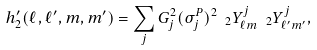<formula> <loc_0><loc_0><loc_500><loc_500>h ^ { \prime } _ { 2 } ( \ell , \ell ^ { \prime } , m , m ^ { \prime } ) = \sum _ { j } G _ { j } ^ { 2 } ( \sigma ^ { P } _ { j } ) ^ { 2 } \ _ { 2 } Y _ { \ell m } ^ { j } \ _ { 2 } Y _ { \ell ^ { \prime } m ^ { \prime } } ^ { j } ,</formula> 